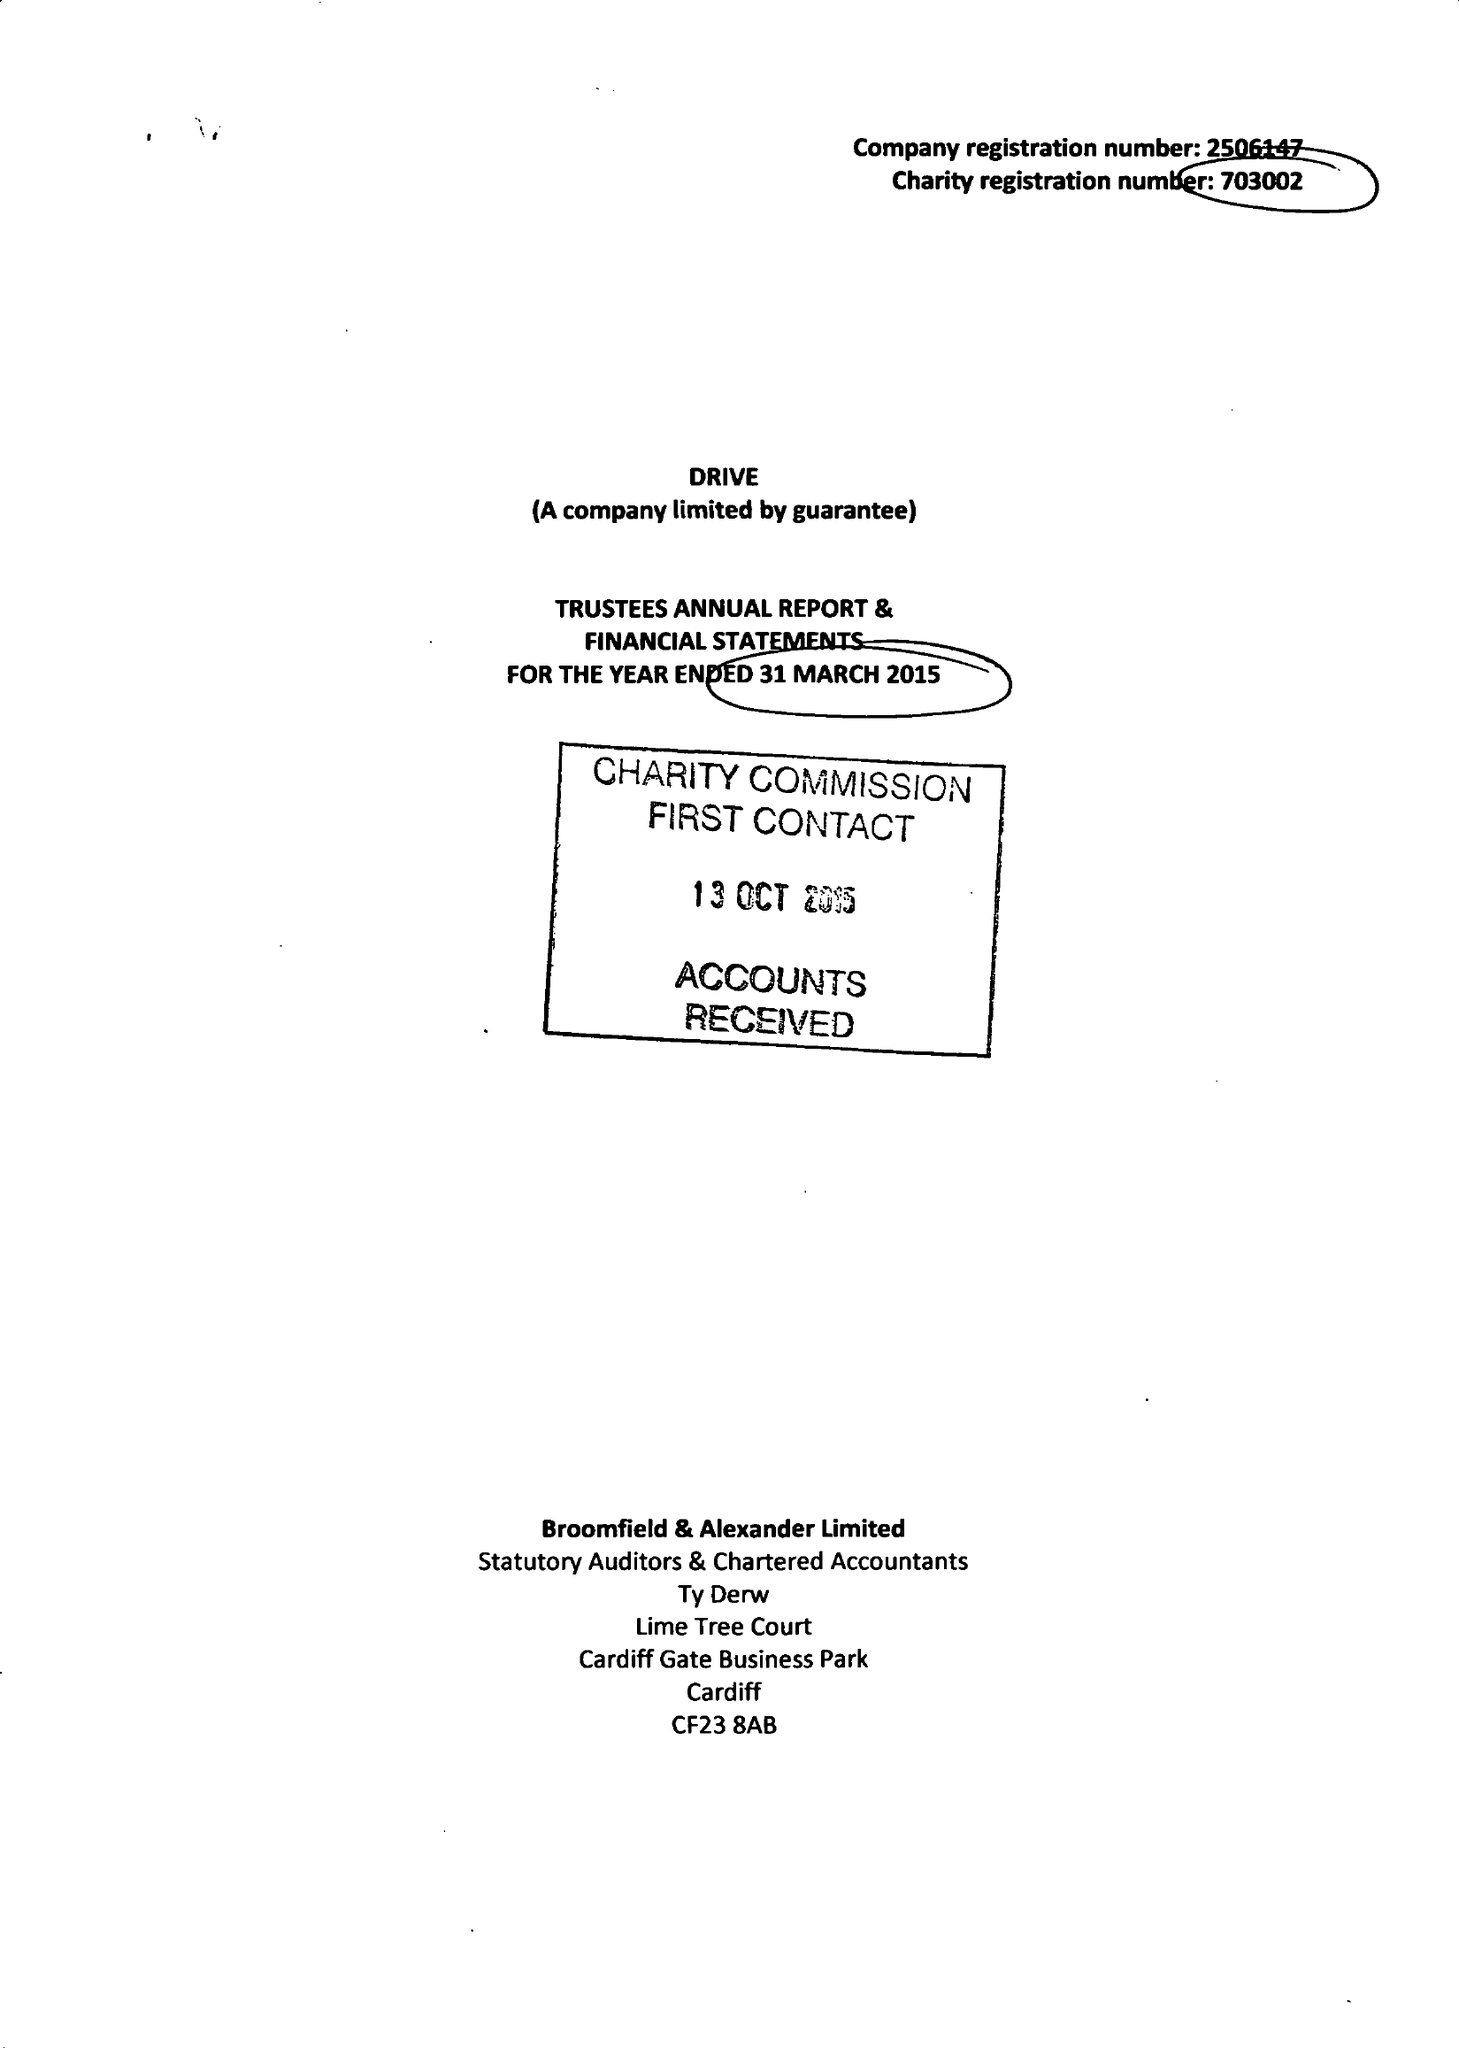What is the value for the report_date?
Answer the question using a single word or phrase. 2015-03-31 